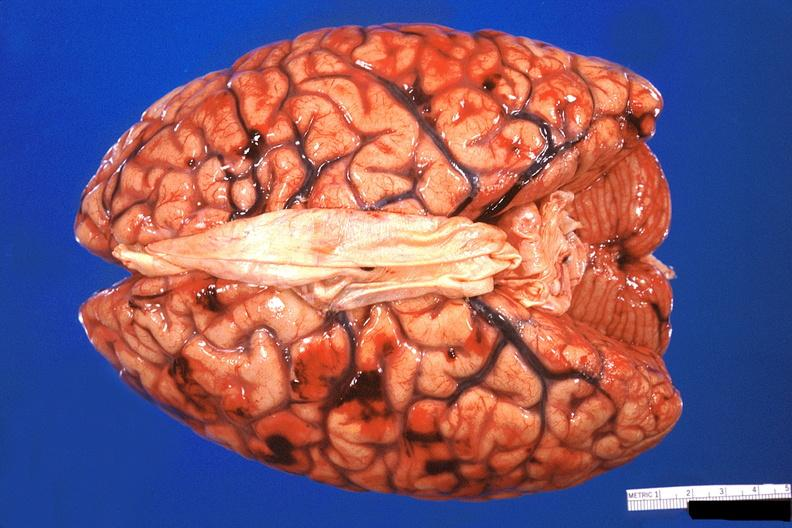s this section showing liver with tumor mass in hilar area tumor present?
Answer the question using a single word or phrase. No 